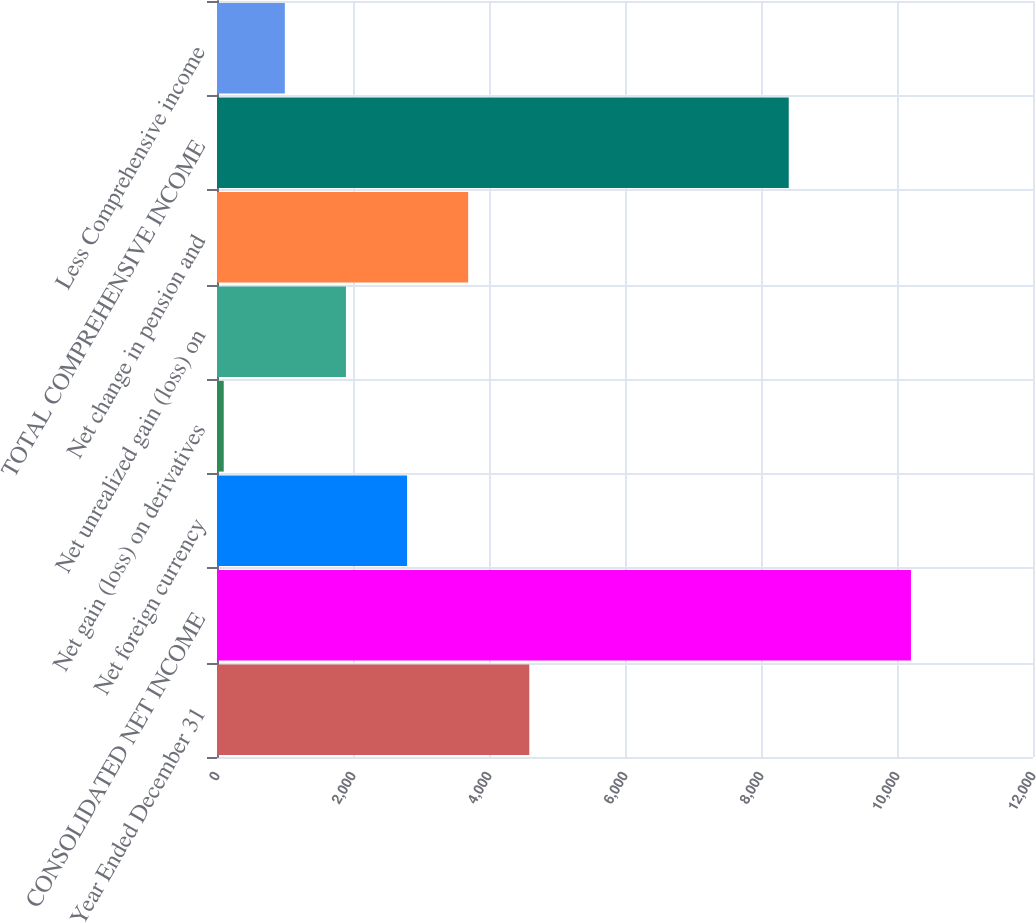<chart> <loc_0><loc_0><loc_500><loc_500><bar_chart><fcel>Year Ended December 31<fcel>CONSOLIDATED NET INCOME<fcel>Net foreign currency<fcel>Net gain (loss) on derivatives<fcel>Net unrealized gain (loss) on<fcel>Net change in pension and<fcel>TOTAL COMPREHENSIVE INCOME<fcel>Less Comprehensive income<nl><fcel>4592.5<fcel>10205.4<fcel>2795.1<fcel>99<fcel>1896.4<fcel>3693.8<fcel>8408<fcel>997.7<nl></chart> 